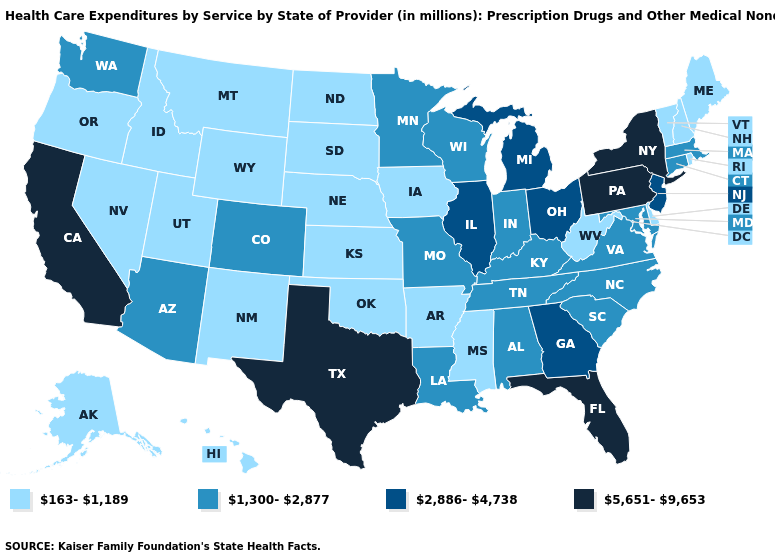What is the value of Washington?
Answer briefly. 1,300-2,877. Does Rhode Island have the highest value in the Northeast?
Short answer required. No. Does the map have missing data?
Keep it brief. No. Does New Hampshire have a lower value than Kentucky?
Short answer required. Yes. Is the legend a continuous bar?
Short answer required. No. What is the value of Nebraska?
Give a very brief answer. 163-1,189. What is the value of Arizona?
Quick response, please. 1,300-2,877. Does Pennsylvania have a higher value than Rhode Island?
Answer briefly. Yes. Name the states that have a value in the range 163-1,189?
Answer briefly. Alaska, Arkansas, Delaware, Hawaii, Idaho, Iowa, Kansas, Maine, Mississippi, Montana, Nebraska, Nevada, New Hampshire, New Mexico, North Dakota, Oklahoma, Oregon, Rhode Island, South Dakota, Utah, Vermont, West Virginia, Wyoming. How many symbols are there in the legend?
Write a very short answer. 4. Among the states that border Nevada , which have the highest value?
Short answer required. California. Does the first symbol in the legend represent the smallest category?
Quick response, please. Yes. Does Alabama have the highest value in the USA?
Quick response, please. No. Does New York have the highest value in the USA?
Write a very short answer. Yes. Does Kansas have the lowest value in the USA?
Quick response, please. Yes. 